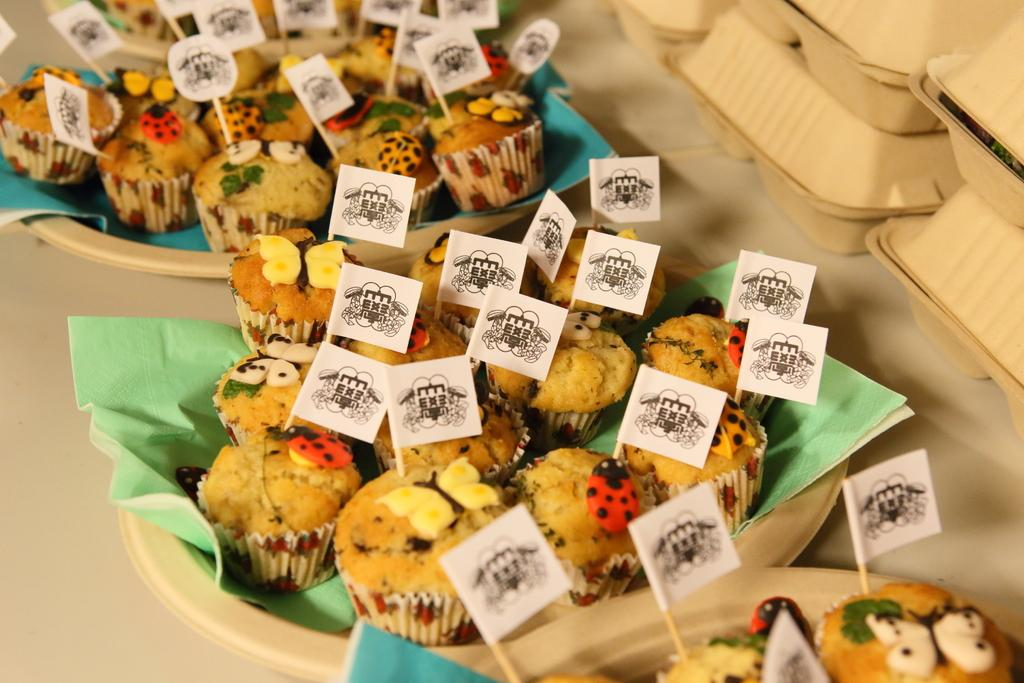What is present on the plates in the image? There is food on plates in the image. What other objects can be seen in the image besides the plates with food? There are boxes in the image. Can you see a shirt hanging from the swing in the image? There is no swing or shirt present in the image. Is there a wren perched on top of the boxes in the image? There is no wren present in the image. 